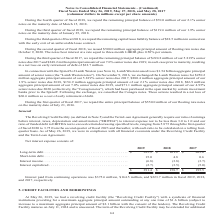According to Conagra Brands's financial document, What is the required ratio of earnings before interest, taxes, depreciation, and amortization ("EBITDA") to interest expense by The Revolving Credit Facility and the Term Loan Agreement? not to be less than 3.0 to 1.0. The document states: "n and amortization ("EBITDA") to interest expense not to be less than 3.0 to 1.0 and our ratio of funded debt to EBITDA not to exceed certain decreasi..." Also, What were the interests paid from continuing operations in the fiscal year 2017 and 2018, respectively? The document shows two values: $223.7 million and $164.5 million. From the document: "operations was $375.6 million, $164.5 million, and $223.7 million in fiscal 2019, 2018, aid from continuing operations was $375.6 million, $164.5 mill..." Also, What were the net interest expenses of short-term debt in the fiscal year 2018 and 2019, respectively? The document shows two values: 4.8 and 15.0 (in millions). From the document: ", we repaid the remaining principal balance of $224.8 million of our 5.819% senior Short-term debt. . 15.0 4.8 0.6..." Also, can you calculate: What is the ratio of net interest expense of long-term debt to interest paid from continuing operations in 2019? Based on the calculation: 385.9/375.6 , the result is 1.03. This is based on the information: "Long-term debt. . $ 385.9 $ 161.2 $ 203.6 Interest paid from continuing operations was $375.6 million, $164.5 million, and $223.7 million in fiscal 2019, 2018,..." The key data points involved are: 375.6, 385.9. Additionally, Which year has the highest total net interest expense? According to the financial document, 2019. The relevant text states: "2019 2018 2017..." Also, can you calculate: What is the percentage change in net interest expense of long-term debt from 2018 to 2019? To answer this question, I need to perform calculations using the financial data. The calculation is: (385.9-161.2)/161.2 , which equals 139.39 (percentage). This is based on the information: "Long-term debt. . $ 385.9 $ 161.2 $ 203.6 Long-term debt. . $ 385.9 $ 161.2 $ 203.6..." The key data points involved are: 161.2, 385.9. 